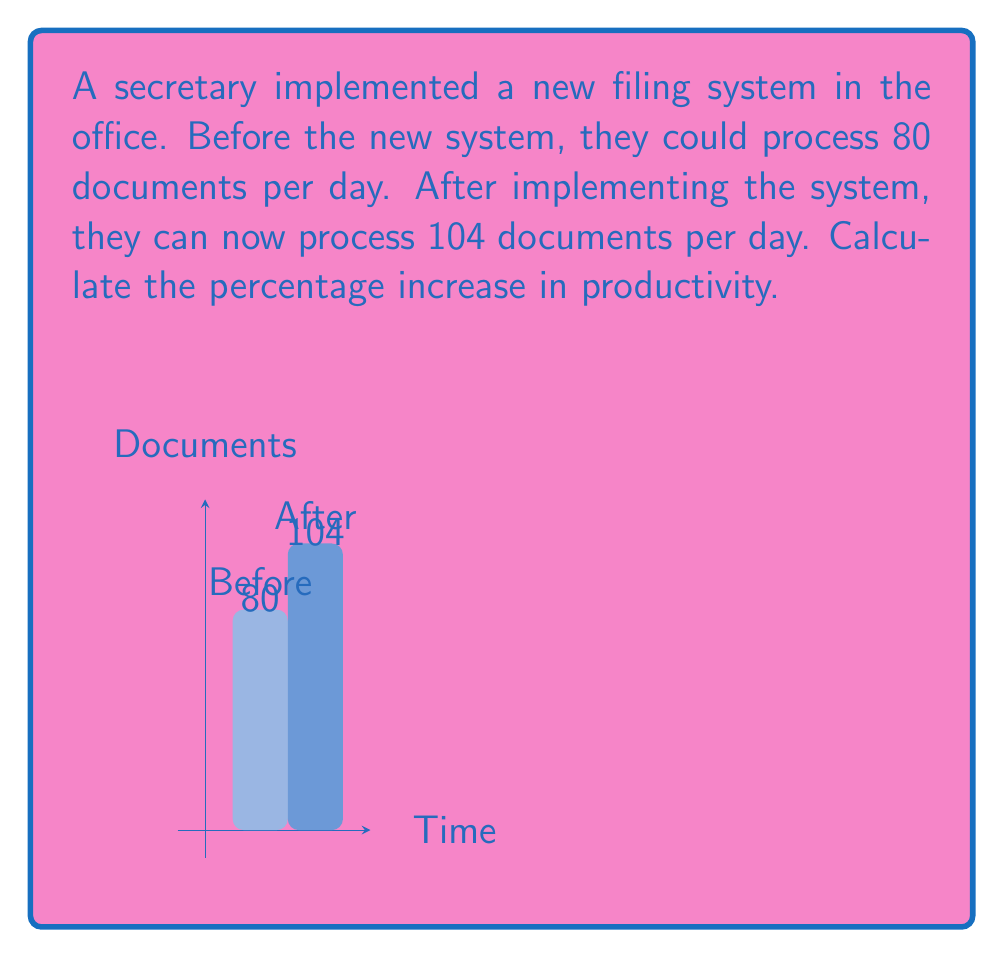Can you answer this question? To calculate the percentage increase in productivity, we'll use the formula:

$$ \text{Percentage Increase} = \frac{\text{Increase}}{\text{Original Value}} \times 100\% $$

Step 1: Calculate the increase in documents processed
$$ \text{Increase} = \text{New Value} - \text{Original Value} $$
$$ \text{Increase} = 104 - 80 = 24 \text{ documents} $$

Step 2: Divide the increase by the original value
$$ \frac{\text{Increase}}{\text{Original Value}} = \frac{24}{80} = 0.3 $$

Step 3: Convert to percentage by multiplying by 100%
$$ 0.3 \times 100\% = 30\% $$

Therefore, the percentage increase in productivity is 30%.
Answer: 30% 